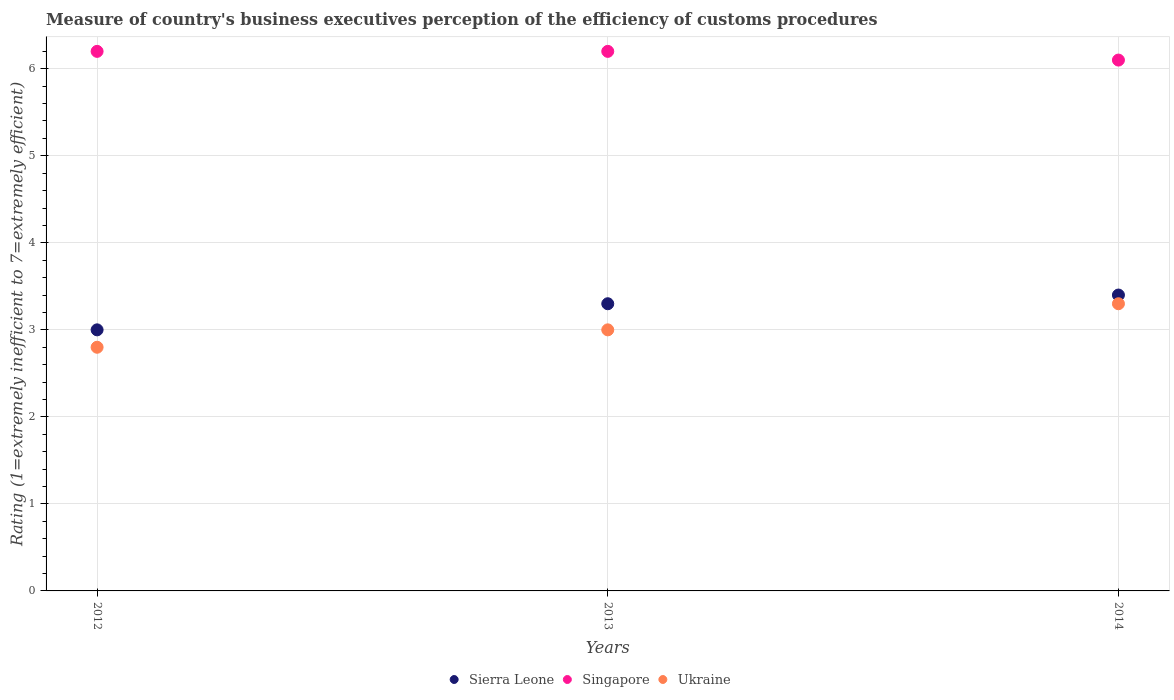How many different coloured dotlines are there?
Make the answer very short. 3. Across all years, what is the maximum rating of the efficiency of customs procedure in Sierra Leone?
Make the answer very short. 3.4. In which year was the rating of the efficiency of customs procedure in Sierra Leone maximum?
Keep it short and to the point. 2014. In which year was the rating of the efficiency of customs procedure in Sierra Leone minimum?
Make the answer very short. 2012. What is the total rating of the efficiency of customs procedure in Ukraine in the graph?
Provide a succinct answer. 9.1. What is the difference between the rating of the efficiency of customs procedure in Sierra Leone in 2012 and that in 2014?
Make the answer very short. -0.4. What is the difference between the rating of the efficiency of customs procedure in Ukraine in 2013 and the rating of the efficiency of customs procedure in Singapore in 2012?
Offer a terse response. -3.2. What is the average rating of the efficiency of customs procedure in Ukraine per year?
Make the answer very short. 3.03. What is the ratio of the rating of the efficiency of customs procedure in Singapore in 2013 to that in 2014?
Offer a terse response. 1.02. Is the rating of the efficiency of customs procedure in Singapore in 2013 less than that in 2014?
Offer a very short reply. No. What is the difference between the highest and the second highest rating of the efficiency of customs procedure in Sierra Leone?
Offer a very short reply. 0.1. Is the sum of the rating of the efficiency of customs procedure in Ukraine in 2013 and 2014 greater than the maximum rating of the efficiency of customs procedure in Sierra Leone across all years?
Your answer should be compact. Yes. Is it the case that in every year, the sum of the rating of the efficiency of customs procedure in Ukraine and rating of the efficiency of customs procedure in Sierra Leone  is greater than the rating of the efficiency of customs procedure in Singapore?
Your answer should be compact. No. What is the difference between two consecutive major ticks on the Y-axis?
Offer a very short reply. 1. How many legend labels are there?
Your answer should be compact. 3. How are the legend labels stacked?
Make the answer very short. Horizontal. What is the title of the graph?
Provide a succinct answer. Measure of country's business executives perception of the efficiency of customs procedures. Does "Jordan" appear as one of the legend labels in the graph?
Make the answer very short. No. What is the label or title of the Y-axis?
Your answer should be compact. Rating (1=extremely inefficient to 7=extremely efficient). What is the Rating (1=extremely inefficient to 7=extremely efficient) of Sierra Leone in 2012?
Offer a terse response. 3. What is the Rating (1=extremely inefficient to 7=extremely efficient) of Singapore in 2012?
Offer a very short reply. 6.2. What is the Rating (1=extremely inefficient to 7=extremely efficient) in Ukraine in 2013?
Provide a succinct answer. 3. What is the Rating (1=extremely inefficient to 7=extremely efficient) in Sierra Leone in 2014?
Offer a terse response. 3.4. What is the Rating (1=extremely inefficient to 7=extremely efficient) in Ukraine in 2014?
Your response must be concise. 3.3. Across all years, what is the maximum Rating (1=extremely inefficient to 7=extremely efficient) of Ukraine?
Your answer should be very brief. 3.3. Across all years, what is the minimum Rating (1=extremely inefficient to 7=extremely efficient) in Ukraine?
Your answer should be very brief. 2.8. What is the difference between the Rating (1=extremely inefficient to 7=extremely efficient) in Sierra Leone in 2012 and that in 2013?
Your answer should be compact. -0.3. What is the difference between the Rating (1=extremely inefficient to 7=extremely efficient) of Singapore in 2012 and that in 2013?
Make the answer very short. 0. What is the difference between the Rating (1=extremely inefficient to 7=extremely efficient) of Ukraine in 2012 and that in 2013?
Your response must be concise. -0.2. What is the difference between the Rating (1=extremely inefficient to 7=extremely efficient) of Sierra Leone in 2012 and that in 2014?
Your response must be concise. -0.4. What is the difference between the Rating (1=extremely inefficient to 7=extremely efficient) of Singapore in 2013 and that in 2014?
Give a very brief answer. 0.1. What is the difference between the Rating (1=extremely inefficient to 7=extremely efficient) of Ukraine in 2013 and that in 2014?
Offer a very short reply. -0.3. What is the difference between the Rating (1=extremely inefficient to 7=extremely efficient) in Sierra Leone in 2012 and the Rating (1=extremely inefficient to 7=extremely efficient) in Ukraine in 2013?
Offer a terse response. 0. What is the difference between the Rating (1=extremely inefficient to 7=extremely efficient) in Sierra Leone in 2012 and the Rating (1=extremely inefficient to 7=extremely efficient) in Singapore in 2014?
Offer a terse response. -3.1. What is the difference between the Rating (1=extremely inefficient to 7=extremely efficient) of Singapore in 2012 and the Rating (1=extremely inefficient to 7=extremely efficient) of Ukraine in 2014?
Offer a very short reply. 2.9. What is the difference between the Rating (1=extremely inefficient to 7=extremely efficient) in Sierra Leone in 2013 and the Rating (1=extremely inefficient to 7=extremely efficient) in Singapore in 2014?
Your answer should be compact. -2.8. What is the average Rating (1=extremely inefficient to 7=extremely efficient) in Sierra Leone per year?
Your response must be concise. 3.23. What is the average Rating (1=extremely inefficient to 7=extremely efficient) of Singapore per year?
Make the answer very short. 6.17. What is the average Rating (1=extremely inefficient to 7=extremely efficient) in Ukraine per year?
Your response must be concise. 3.03. In the year 2012, what is the difference between the Rating (1=extremely inefficient to 7=extremely efficient) in Sierra Leone and Rating (1=extremely inefficient to 7=extremely efficient) in Singapore?
Your answer should be compact. -3.2. In the year 2012, what is the difference between the Rating (1=extremely inefficient to 7=extremely efficient) of Sierra Leone and Rating (1=extremely inefficient to 7=extremely efficient) of Ukraine?
Provide a short and direct response. 0.2. In the year 2014, what is the difference between the Rating (1=extremely inefficient to 7=extremely efficient) in Sierra Leone and Rating (1=extremely inefficient to 7=extremely efficient) in Singapore?
Your answer should be compact. -2.7. In the year 2014, what is the difference between the Rating (1=extremely inefficient to 7=extremely efficient) of Sierra Leone and Rating (1=extremely inefficient to 7=extremely efficient) of Ukraine?
Your answer should be compact. 0.1. In the year 2014, what is the difference between the Rating (1=extremely inefficient to 7=extremely efficient) in Singapore and Rating (1=extremely inefficient to 7=extremely efficient) in Ukraine?
Provide a succinct answer. 2.8. What is the ratio of the Rating (1=extremely inefficient to 7=extremely efficient) of Ukraine in 2012 to that in 2013?
Give a very brief answer. 0.93. What is the ratio of the Rating (1=extremely inefficient to 7=extremely efficient) in Sierra Leone in 2012 to that in 2014?
Provide a succinct answer. 0.88. What is the ratio of the Rating (1=extremely inefficient to 7=extremely efficient) in Singapore in 2012 to that in 2014?
Give a very brief answer. 1.02. What is the ratio of the Rating (1=extremely inefficient to 7=extremely efficient) of Ukraine in 2012 to that in 2014?
Keep it short and to the point. 0.85. What is the ratio of the Rating (1=extremely inefficient to 7=extremely efficient) of Sierra Leone in 2013 to that in 2014?
Provide a succinct answer. 0.97. What is the ratio of the Rating (1=extremely inefficient to 7=extremely efficient) of Singapore in 2013 to that in 2014?
Your answer should be compact. 1.02. What is the ratio of the Rating (1=extremely inefficient to 7=extremely efficient) in Ukraine in 2013 to that in 2014?
Keep it short and to the point. 0.91. What is the difference between the highest and the second highest Rating (1=extremely inefficient to 7=extremely efficient) in Singapore?
Offer a terse response. 0. What is the difference between the highest and the second highest Rating (1=extremely inefficient to 7=extremely efficient) of Ukraine?
Offer a very short reply. 0.3. 